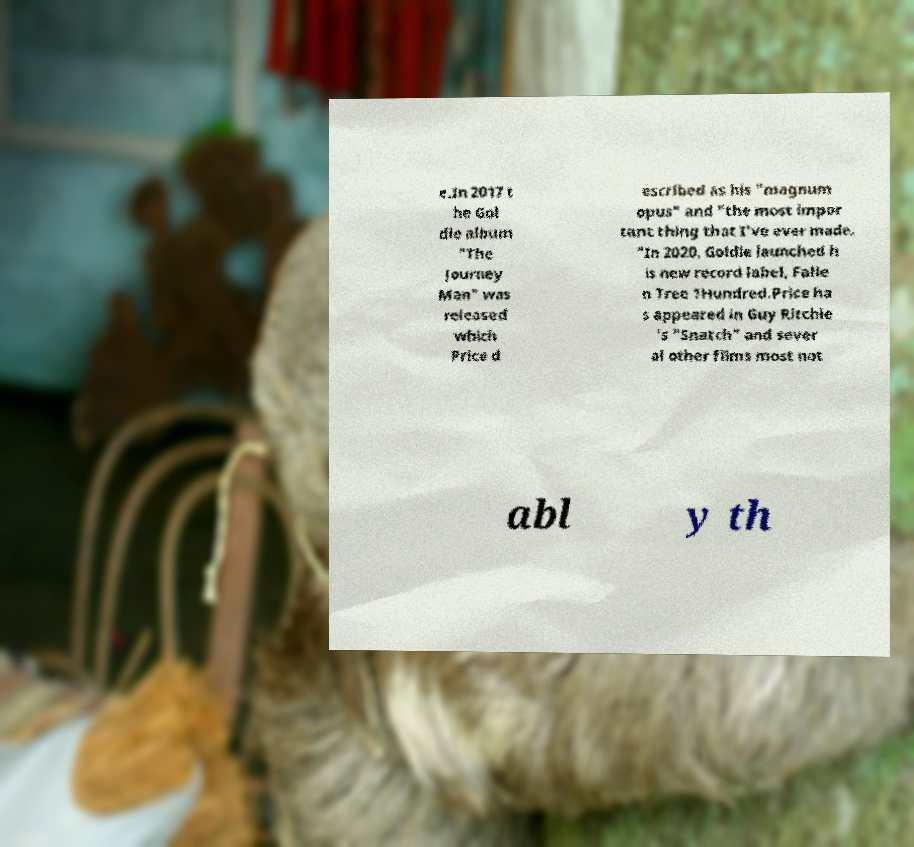Could you extract and type out the text from this image? e.In 2017 t he Gol die album "The Journey Man" was released which Price d escribed as his "magnum opus" and "the most impor tant thing that I've ever made. "In 2020, Goldie launched h is new record label, Falle n Tree 1Hundred.Price ha s appeared in Guy Ritchie 's "Snatch" and sever al other films most not abl y th 